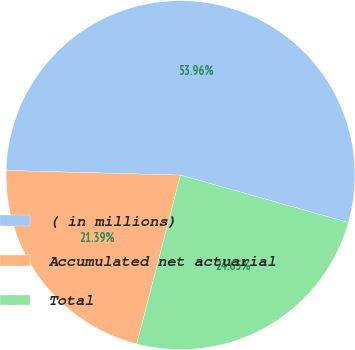Convert chart. <chart><loc_0><loc_0><loc_500><loc_500><pie_chart><fcel>( in millions)<fcel>Accumulated net actuarial<fcel>Total<nl><fcel>53.96%<fcel>21.39%<fcel>24.65%<nl></chart> 